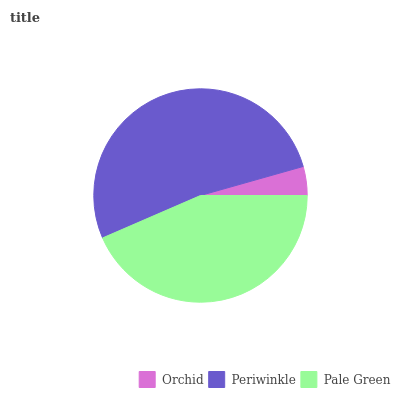Is Orchid the minimum?
Answer yes or no. Yes. Is Periwinkle the maximum?
Answer yes or no. Yes. Is Pale Green the minimum?
Answer yes or no. No. Is Pale Green the maximum?
Answer yes or no. No. Is Periwinkle greater than Pale Green?
Answer yes or no. Yes. Is Pale Green less than Periwinkle?
Answer yes or no. Yes. Is Pale Green greater than Periwinkle?
Answer yes or no. No. Is Periwinkle less than Pale Green?
Answer yes or no. No. Is Pale Green the high median?
Answer yes or no. Yes. Is Pale Green the low median?
Answer yes or no. Yes. Is Orchid the high median?
Answer yes or no. No. Is Orchid the low median?
Answer yes or no. No. 